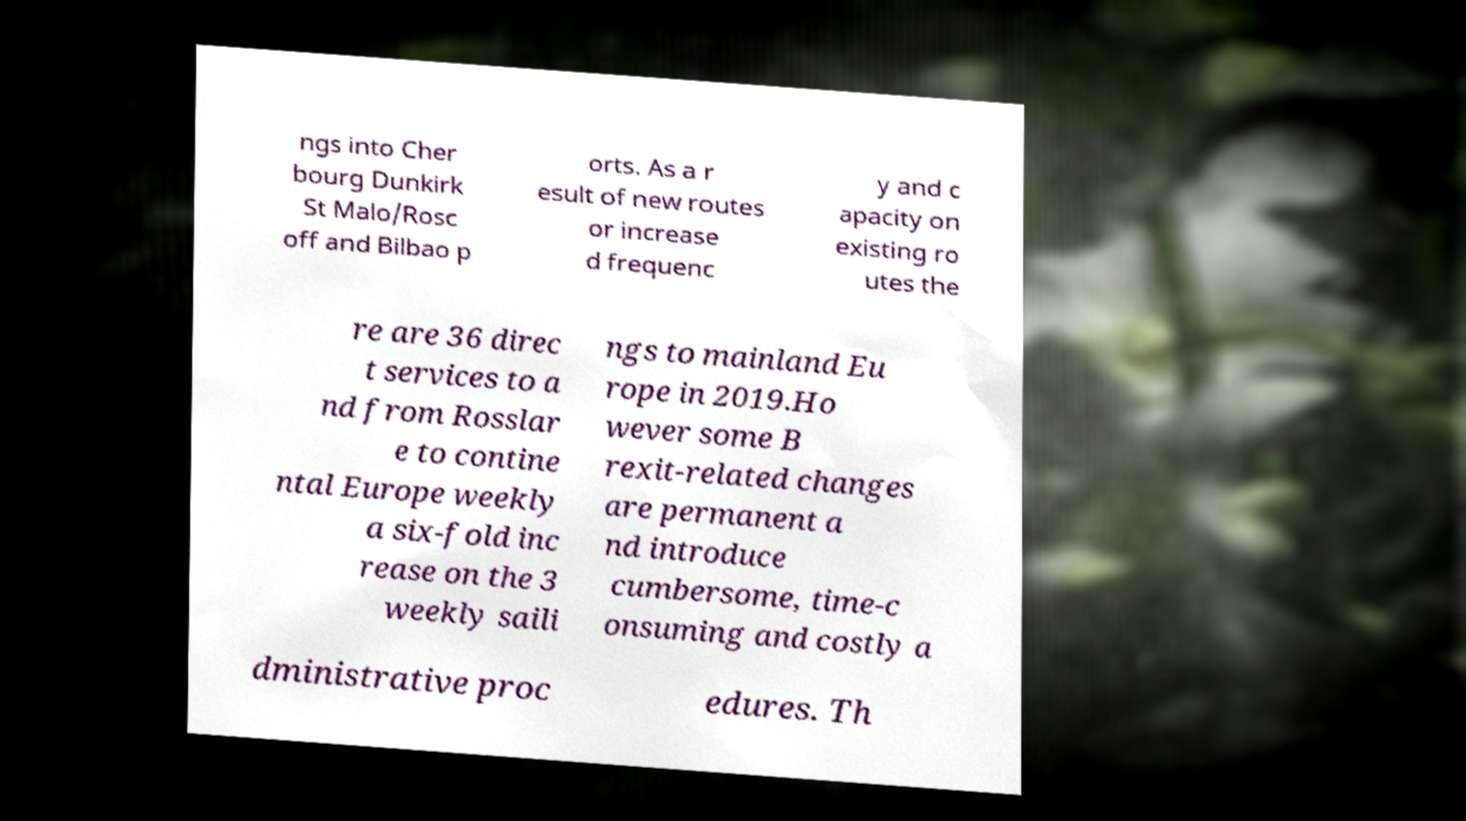Please identify and transcribe the text found in this image. ngs into Cher bourg Dunkirk St Malo/Rosc off and Bilbao p orts. As a r esult of new routes or increase d frequenc y and c apacity on existing ro utes the re are 36 direc t services to a nd from Rosslar e to contine ntal Europe weekly a six-fold inc rease on the 3 weekly saili ngs to mainland Eu rope in 2019.Ho wever some B rexit-related changes are permanent a nd introduce cumbersome, time-c onsuming and costly a dministrative proc edures. Th 